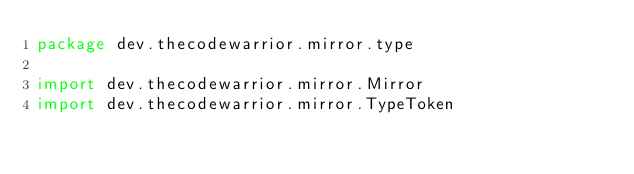Convert code to text. <code><loc_0><loc_0><loc_500><loc_500><_Kotlin_>package dev.thecodewarrior.mirror.type

import dev.thecodewarrior.mirror.Mirror
import dev.thecodewarrior.mirror.TypeToken</code> 